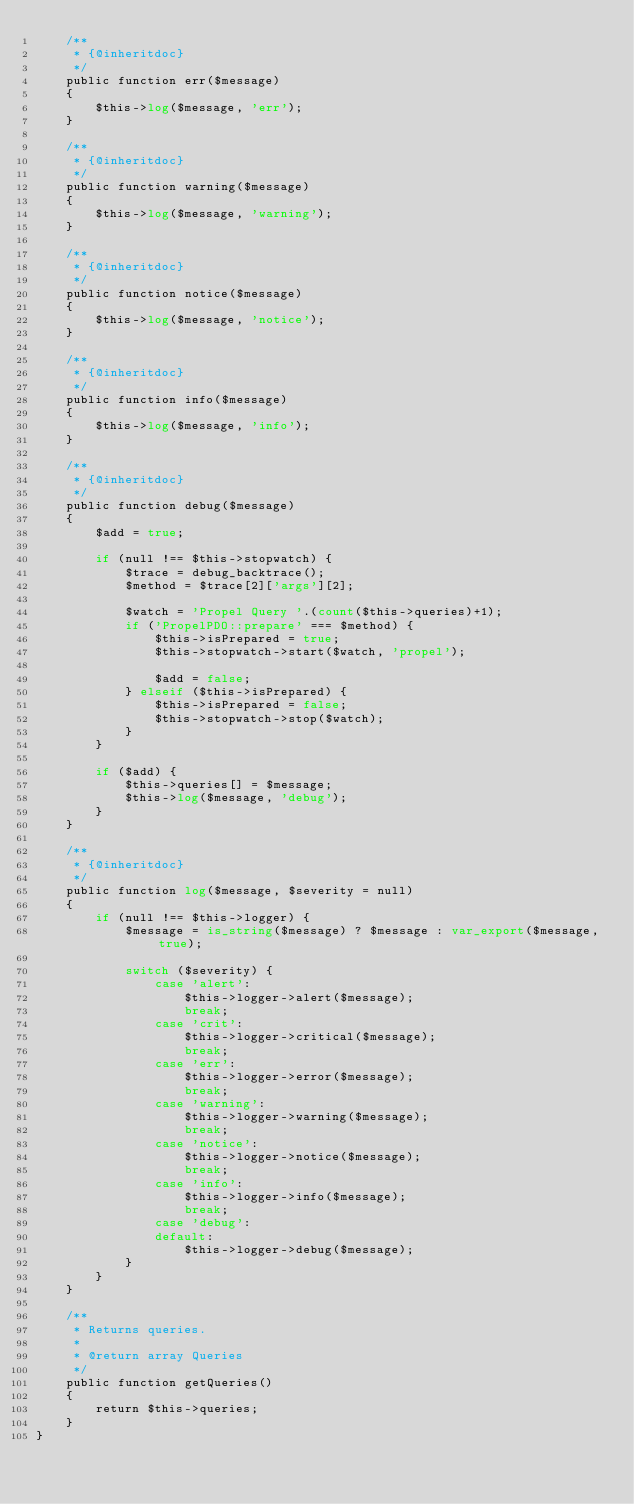<code> <loc_0><loc_0><loc_500><loc_500><_PHP_>    /**
     * {@inheritdoc}
     */
    public function err($message)
    {
        $this->log($message, 'err');
    }

    /**
     * {@inheritdoc}
     */
    public function warning($message)
    {
        $this->log($message, 'warning');
    }

    /**
     * {@inheritdoc}
     */
    public function notice($message)
    {
        $this->log($message, 'notice');
    }

    /**
     * {@inheritdoc}
     */
    public function info($message)
    {
        $this->log($message, 'info');
    }

    /**
     * {@inheritdoc}
     */
    public function debug($message)
    {
        $add = true;

        if (null !== $this->stopwatch) {
            $trace = debug_backtrace();
            $method = $trace[2]['args'][2];

            $watch = 'Propel Query '.(count($this->queries)+1);
            if ('PropelPDO::prepare' === $method) {
                $this->isPrepared = true;
                $this->stopwatch->start($watch, 'propel');

                $add = false;
            } elseif ($this->isPrepared) {
                $this->isPrepared = false;
                $this->stopwatch->stop($watch);
            }
        }

        if ($add) {
            $this->queries[] = $message;
            $this->log($message, 'debug');
        }
    }

    /**
     * {@inheritdoc}
     */
    public function log($message, $severity = null)
    {
        if (null !== $this->logger) {
            $message = is_string($message) ? $message : var_export($message, true);

            switch ($severity) {
                case 'alert':
                    $this->logger->alert($message);
                    break;
                case 'crit':
                    $this->logger->critical($message);
                    break;
                case 'err':
                    $this->logger->error($message);
                    break;
                case 'warning':
                    $this->logger->warning($message);
                    break;
                case 'notice':
                    $this->logger->notice($message);
                    break;
                case 'info':
                    $this->logger->info($message);
                    break;
                case 'debug':
                default:
                    $this->logger->debug($message);
            }
        }
    }

    /**
     * Returns queries.
     *
     * @return array Queries
     */
    public function getQueries()
    {
        return $this->queries;
    }
}
</code> 